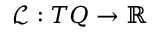Convert formula to latex. <formula><loc_0><loc_0><loc_500><loc_500>\mathcal { L } \colon T Q \rightarrow \mathbb { R }</formula> 